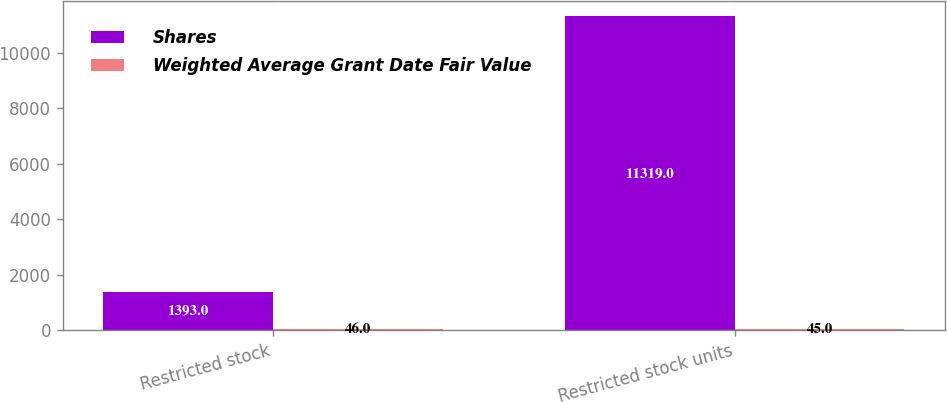Convert chart to OTSL. <chart><loc_0><loc_0><loc_500><loc_500><stacked_bar_chart><ecel><fcel>Restricted stock<fcel>Restricted stock units<nl><fcel>Shares<fcel>1393<fcel>11319<nl><fcel>Weighted Average Grant Date Fair Value<fcel>46<fcel>45<nl></chart> 